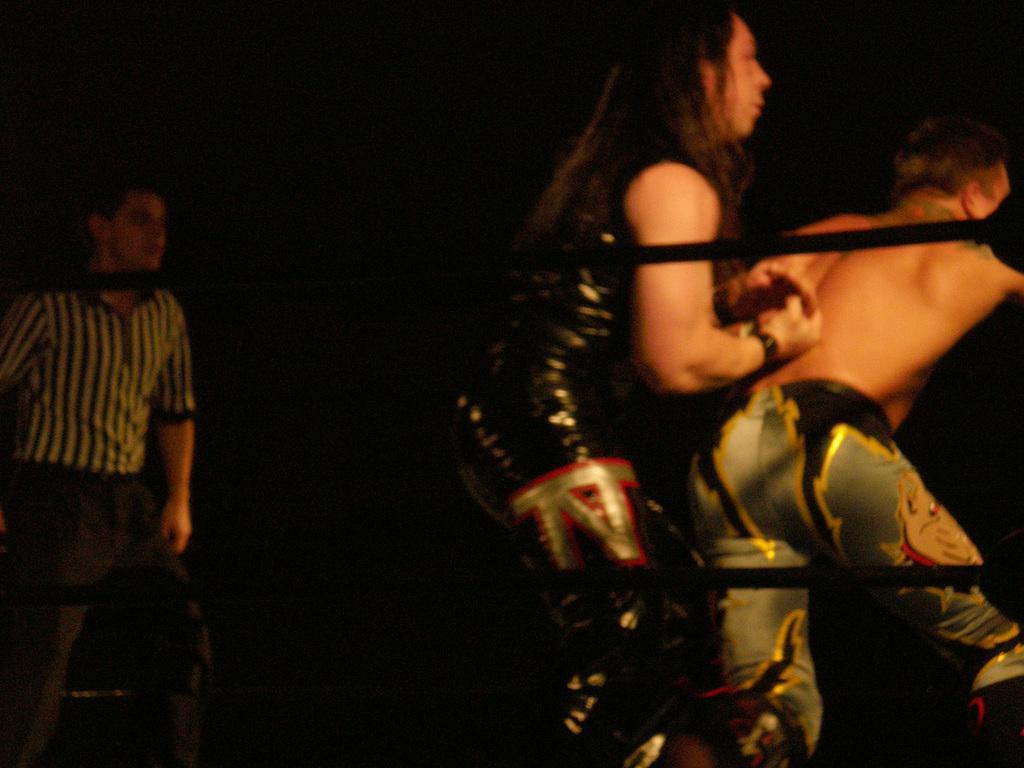Could you give a brief overview of what you see in this image? This image is taken indoors. In this image the background is dark. On the left side of the image a man is standing in the boxing ring. There are two ropes. On the right side of the image two men are fighting in the boxing ring. 